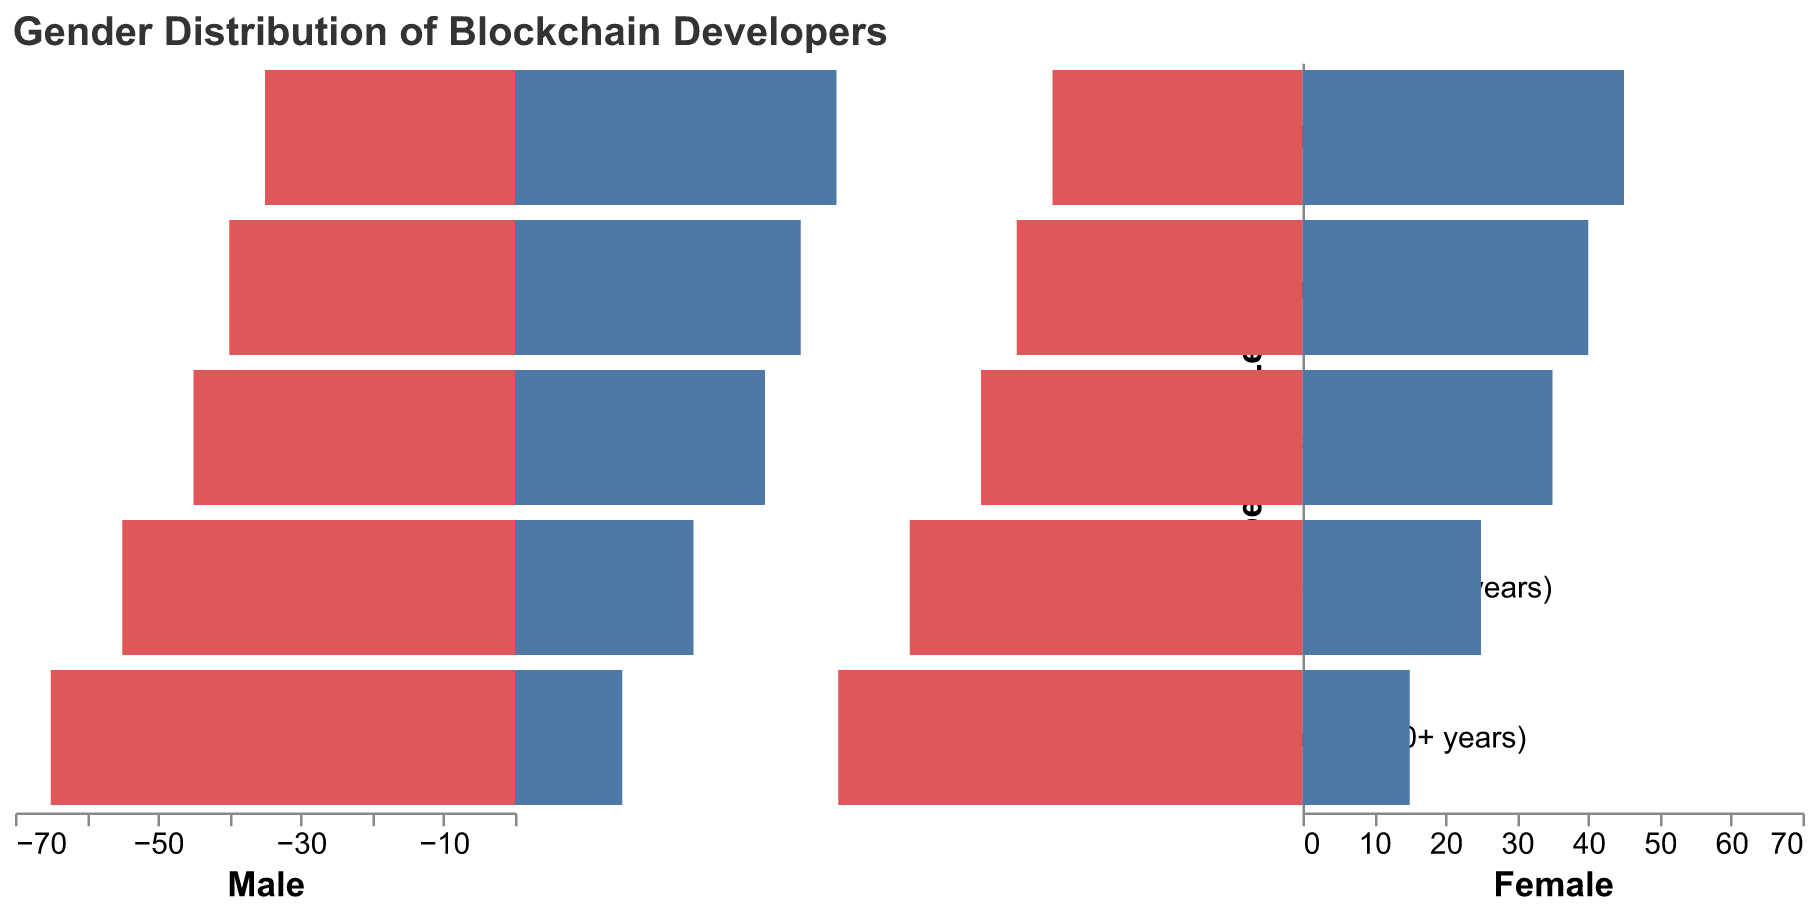What is the title of the figure? The title is displayed at the top of the figure.
Answer: Gender Distribution of Blockchain Developers Which experience level has the most balanced gender distribution? The balance can be observed by comparing the length of the Male and Female bars at each experience level. The Entry-level (0-1 year) category has both Male and Female bars of equal length.
Answer: Entry-level (0-1 year) In which experience level is there the highest number of female blockchain developers? By comparing the lengths of the Female bars at each experience level, the longest Female bar is at the Blockchain Students level.
Answer: Blockchain Students What is the difference between the number of male and female Senior blockchain developers? The number of male Senior developers is 65, and the number of female Senior developers is 15. The difference is 65 - 15.
Answer: 50 Which experience level has the highest number of male blockchain developers? Comparing the lengths of the Male bars at each experience level, the longest Male bar is at the Senior (10+ years) level.
Answer: Senior (10+ years) For which experience levels do males outnumber females by a ratio of 2:1? Calculate 2:1 ratios where Female count multiplied by 2 equals Male count. This occurs at both the Senior (10+ years) level (Male: 65, Female: 15) and the Mid-level (5-9 years) level (Male: 55, Female: 25).
Answer: Senior (10+ years), Mid-level (5-9 years) Which experience level has the lowest participation from female developers? Compare the lengths of the Female bars and find the shortest one, which is at the Senior (10+ years) level.
Answer: Senior (10+ years) How many more male blockchain students are there compared to female blockchain students? The number of male blockchain students is 35, and the number of female blockchain students is 45. The difference is 35 - 45.
Answer: -10 (10 fewer males) What trend can be observed in the gender distribution from Senior to Blockchain Students levels? Observing the figure, the number of males decreases while the number of females increases as we move from Senior to Blockchain Students.
Answer: Male numbers decrease and female numbers increase from Senior to Students Which gender has greater representation overall in the entire blockchain developer community? Summing up the numbers for each gender across all experience levels: Male: 65+55+45+40+35 = 240 and Female: 15+25+35+40+45 = 160. Males: 240, Females: 160.
Answer: Male 